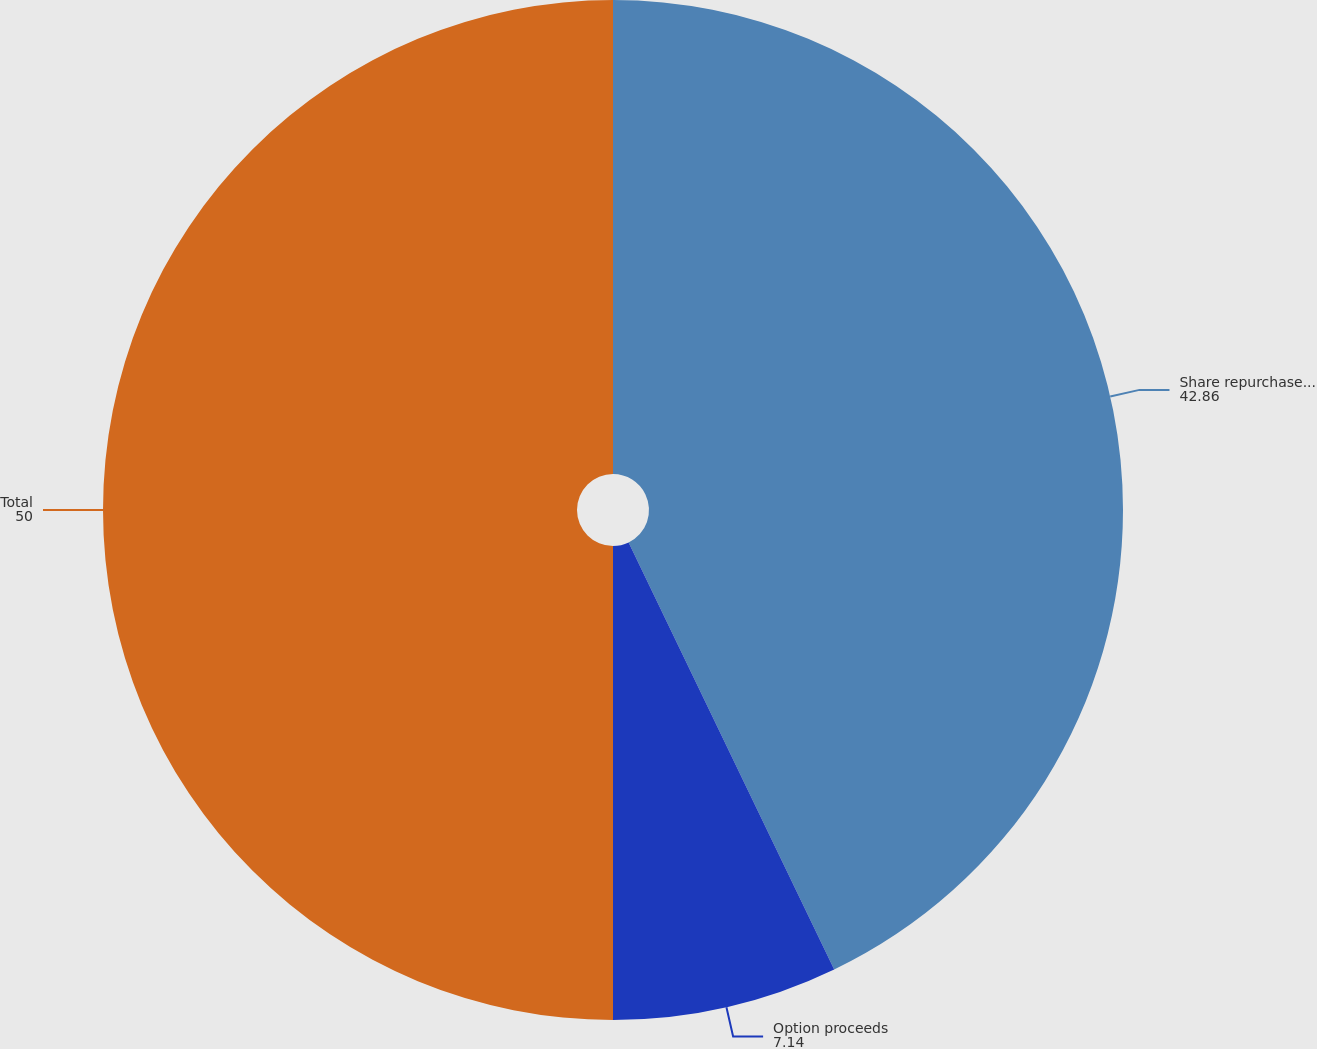<chart> <loc_0><loc_0><loc_500><loc_500><pie_chart><fcel>Share repurchase program<fcel>Option proceeds<fcel>Total<nl><fcel>42.86%<fcel>7.14%<fcel>50.0%<nl></chart> 